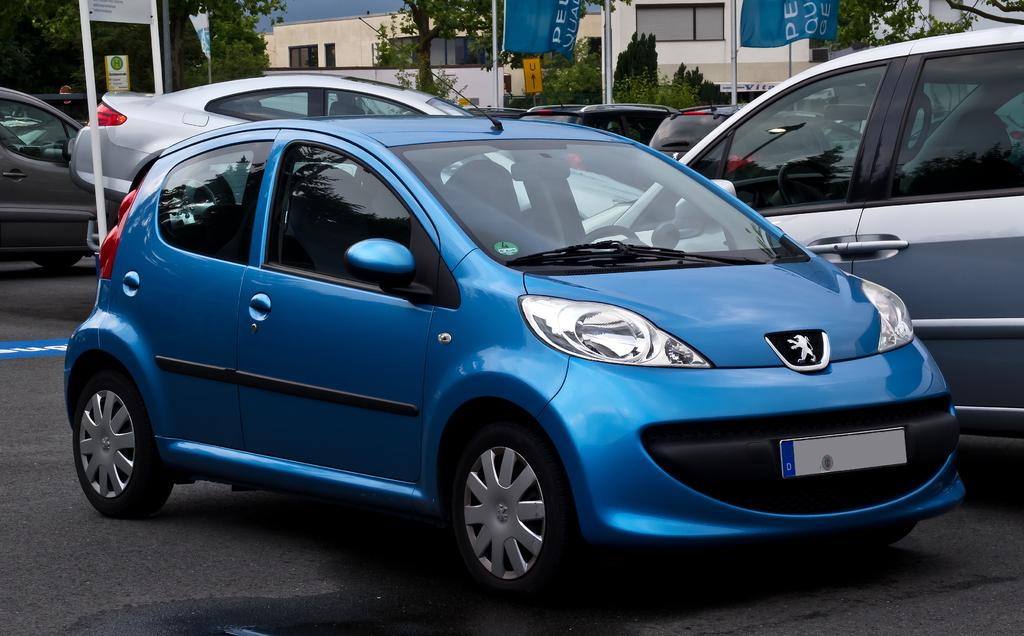What color is the car that is visible in the image? The car in the image is blue. Where is the blue car located in the image? The blue car is on the road. Are there any other cars in the image? Yes, there are other cars behind the blue car. What can be seen in the background of the image? There are buildings and trees in the background of the image. Is there any other object or feature in the background of the image? Yes, there is a flag in front of a building in the background. Can you tell me how many times the blue car kicks the soccer ball in the image? There is no soccer ball present in the image, and therefore no kicking can be observed. 